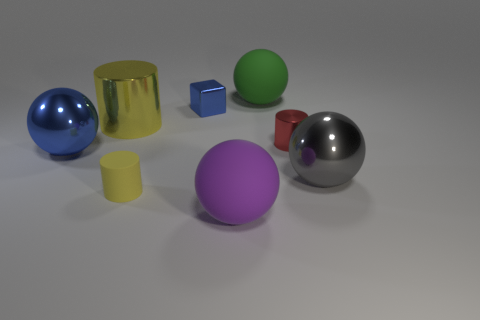Add 1 small yellow things. How many objects exist? 9 Subtract all cylinders. How many objects are left? 5 Subtract all tiny blue matte things. Subtract all balls. How many objects are left? 4 Add 8 purple spheres. How many purple spheres are left? 9 Add 3 shiny cylinders. How many shiny cylinders exist? 5 Subtract 1 gray spheres. How many objects are left? 7 